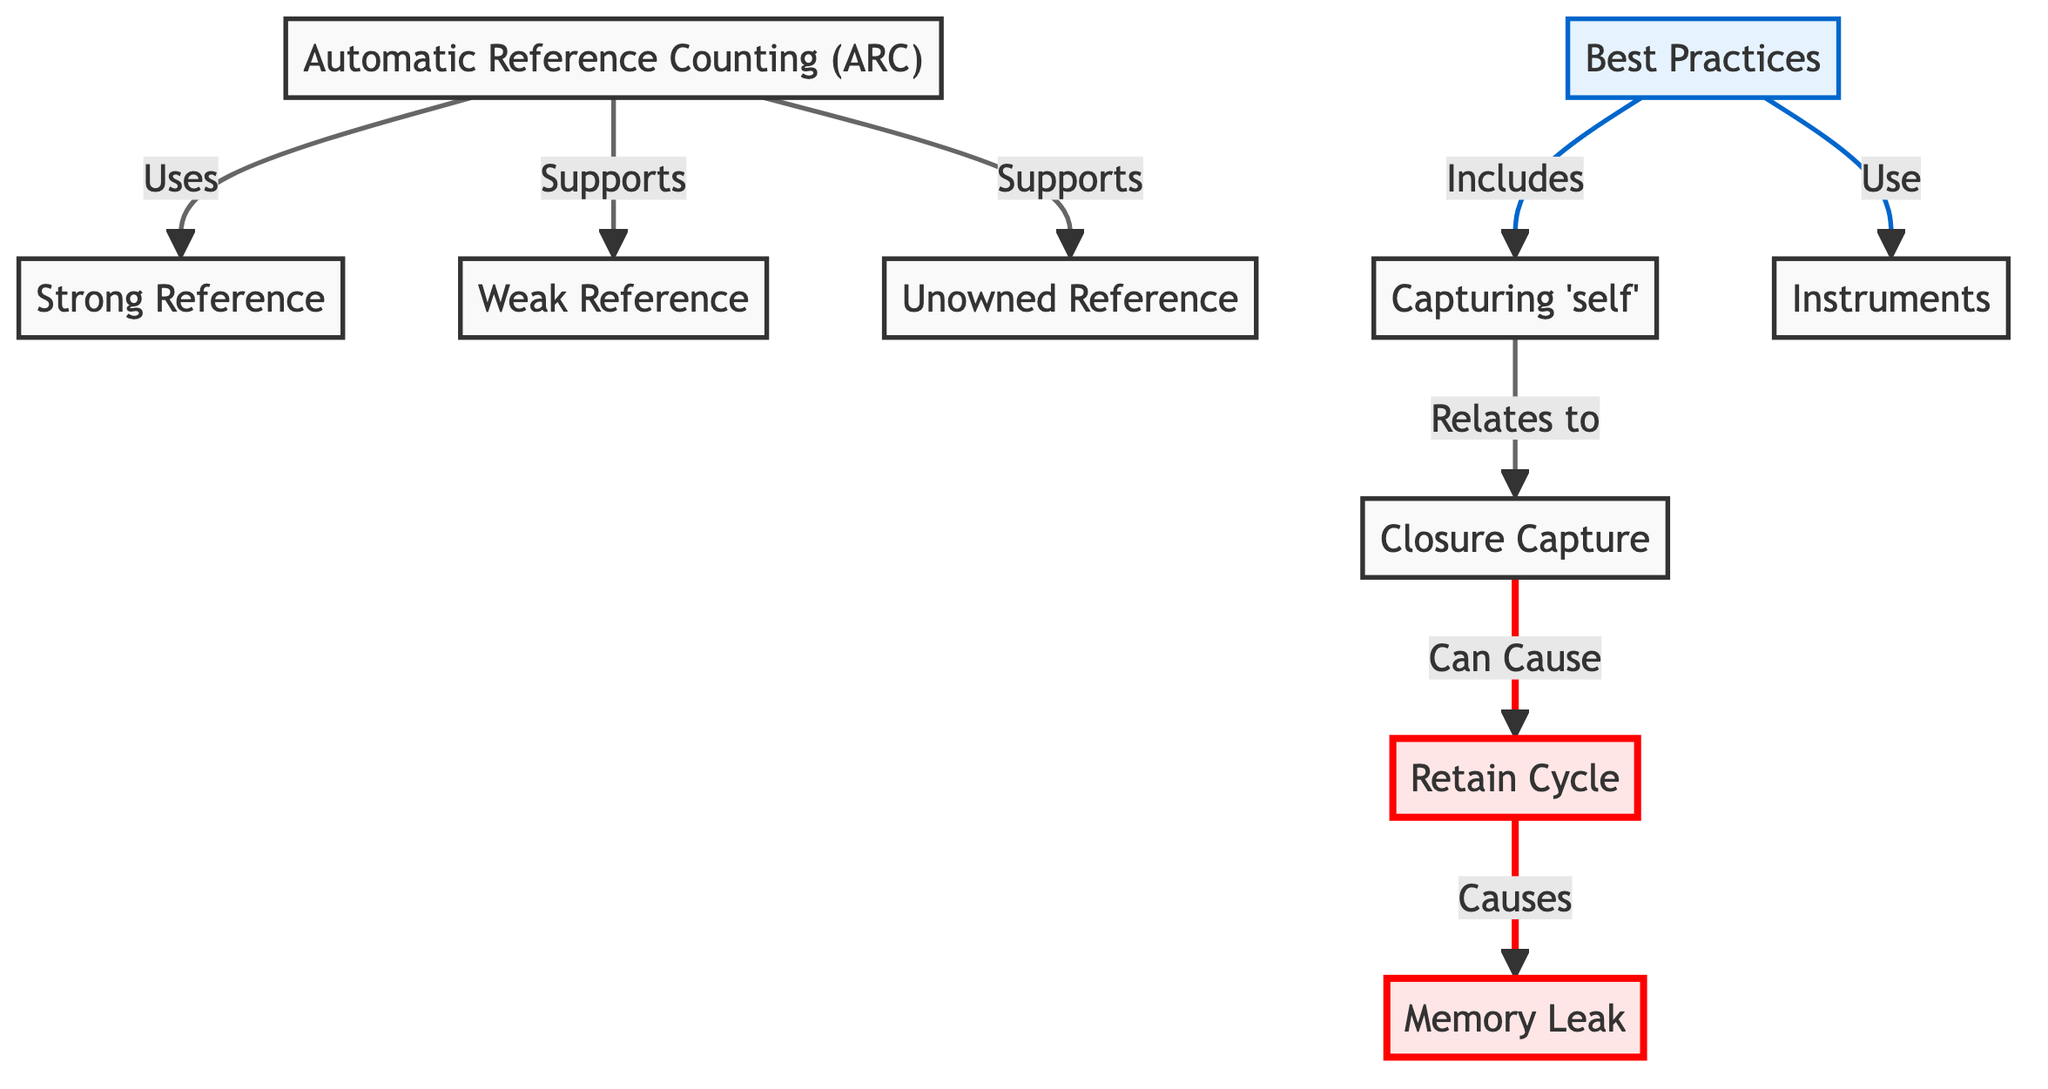What is the main mechanism for memory management in Swift? The diagram explicitly labels "Automatic Reference Counting (ARC)" as the central mechanism for memory management in Swift, indicating its importance in the overall memory management process.
Answer: Automatic Reference Counting (ARC) What do strong references do in ARC? The diagram illustrates that strong references are utilized by ARC, which implies that strong references keep hold of objects, preventing them from being deallocated as long as the reference exists.
Answer: Uses What can cause a retain cycle? The diagram indicates that a retain cycle is caused by the connections between objects that keep each other alive through strong references, leading to a situation where neither can be deallocated.
Answer: Causes What kind of reference does ARC support to avoid memory leaks? The diagram mentions that ARC supports weak references, which means these references do not keep the referenced object alive, thus helping prevent memory leaks.
Answer: Weak Reference What are the best practices for memory management according to the diagram? The diagram outlines that best practices include capturing self and using instruments, which are strategies to avoid issues related to memory management and diagnose potential memory leaks.
Answer: Best Practices What is the relationship between closure capture and retain cycles? The diagram specifies that closure capture can cause retain cycles, meaning that if 'self' is captured strongly within the closure, it can lead to a situation where retain cycles occur, preventing memory from being freed.
Answer: Can Cause How many types of references are mentioned in the diagram? By analyzing the nodes related to references in the diagram, we see three types: strong, weak, and unowned references, thus providing a total of three distinct types indicated.
Answer: Three Which tool is suggested for diagnosing memory issues? The diagram explicitly states that "Instruments" is recommended for identifying and diagnosing memory issues, making it essential for developers to understand their memory usage effectively.
Answer: Instruments 